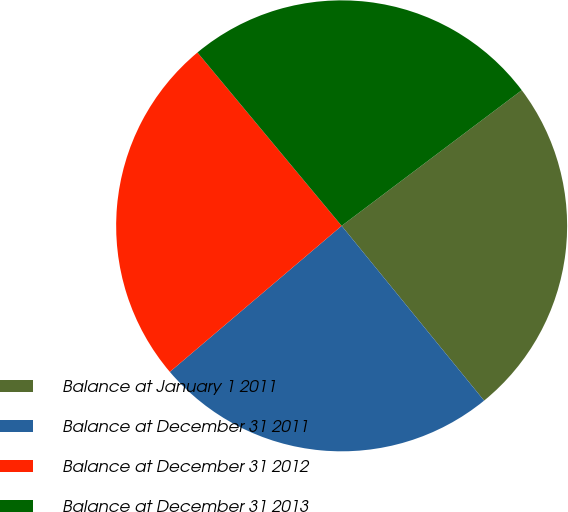<chart> <loc_0><loc_0><loc_500><loc_500><pie_chart><fcel>Balance at January 1 2011<fcel>Balance at December 31 2011<fcel>Balance at December 31 2012<fcel>Balance at December 31 2013<nl><fcel>24.39%<fcel>24.67%<fcel>25.17%<fcel>25.77%<nl></chart> 